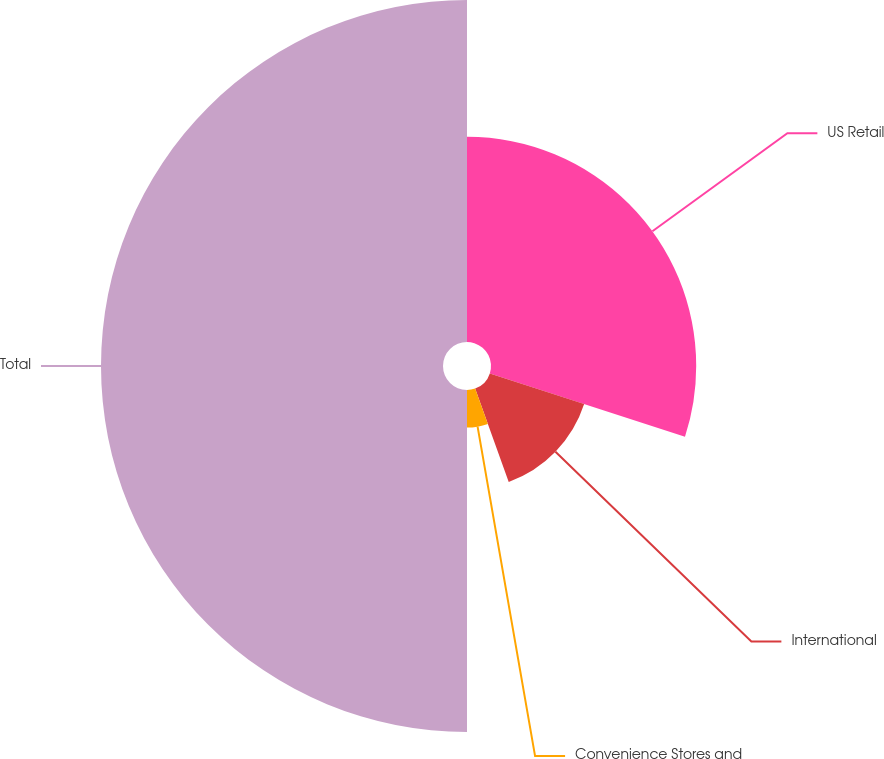Convert chart to OTSL. <chart><loc_0><loc_0><loc_500><loc_500><pie_chart><fcel>US Retail<fcel>International<fcel>Convenience Stores and<fcel>Total<nl><fcel>30.0%<fcel>14.5%<fcel>5.5%<fcel>50.0%<nl></chart> 